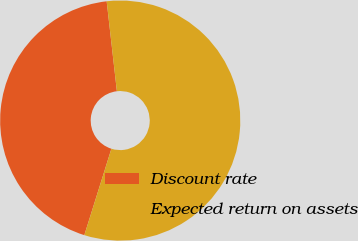Convert chart. <chart><loc_0><loc_0><loc_500><loc_500><pie_chart><fcel>Discount rate<fcel>Expected return on assets<nl><fcel>43.37%<fcel>56.63%<nl></chart> 